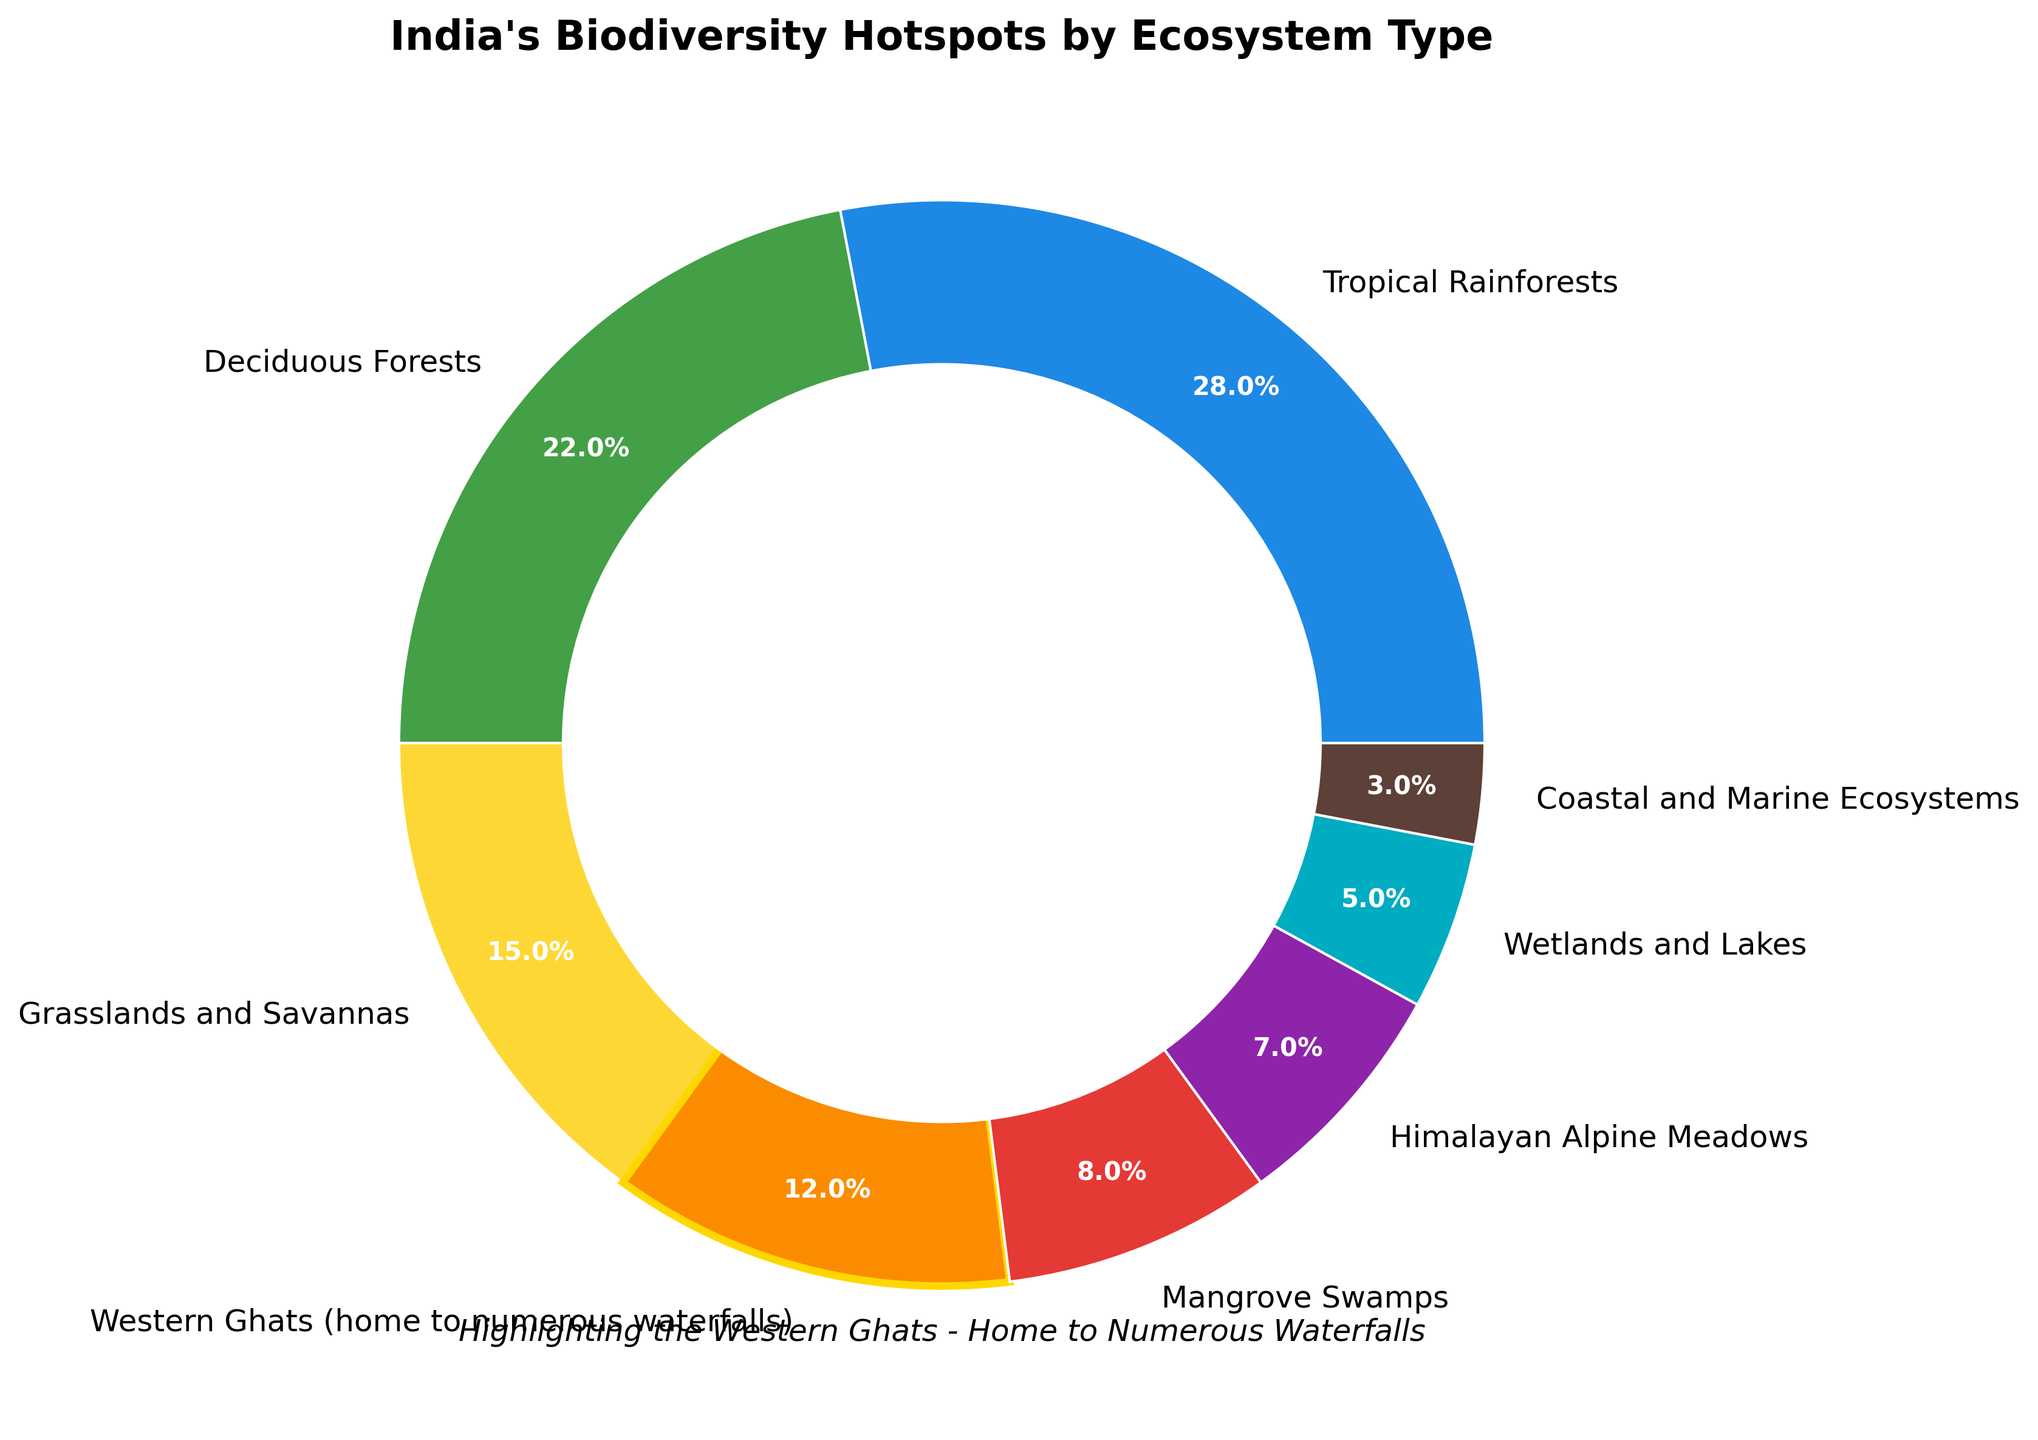what percentage of India's biodiversity hotspots are tropical rainforests and wetlands and lakes combined? First, note the percentage for Tropical Rainforests (28%) and the percentage for Wetlands and Lakes (5%). Then, add the two values: 28% + 5% = 33%.
Answer: 33% Which ecosystem type has the highest representation in India's biodiversity hotspots? Observe the pie chart to identify which segment is the largest. The Tropical Rainforests segment is the largest with 28%.
Answer: Tropical Rainforests What is the difference between the percentage of Western Ghats and Mangrove Swamps in India's biodiversity hotspots? Identify the percentages for Western Ghats (12%) and Mangrove Swamps (8%). Subtract the smaller value from the larger one: 12% - 8% = 4%.
Answer: 4% How is the Western Ghats segment visually emphasized in the pie chart? In the pie chart, the Western Ghats segment is highlighted by a golden edge and a thicker line width compared to other segments.
Answer: golden edge and thicker line width If you combine the percentages of Grasslands and Savannas and Deciduous Forests, how do they compare to the percentage of Tropical Rainforests? Add the percentages of Grasslands and Savannas (15%) and Deciduous Forests (22%) to get 37%. Compare this with the Tropical Rainforests (28%): 37% is greater than 28%.
Answer: greater than 28% Which ecosystems have a smaller percentage than the Western Ghats? The Western Ghats have a percentage of 12%. The ecosystems with smaller percentages are Mangrove Swamps (8%), Himalayan Alpine Meadows (7%), Wetlands and Lakes (5%), and Coastal and Marine Ecosystems (3%).
Answer: Mangrove Swamps, Himalayan Alpine Meadows, Wetlands and Lakes, Coastal and Marine Ecosystems 